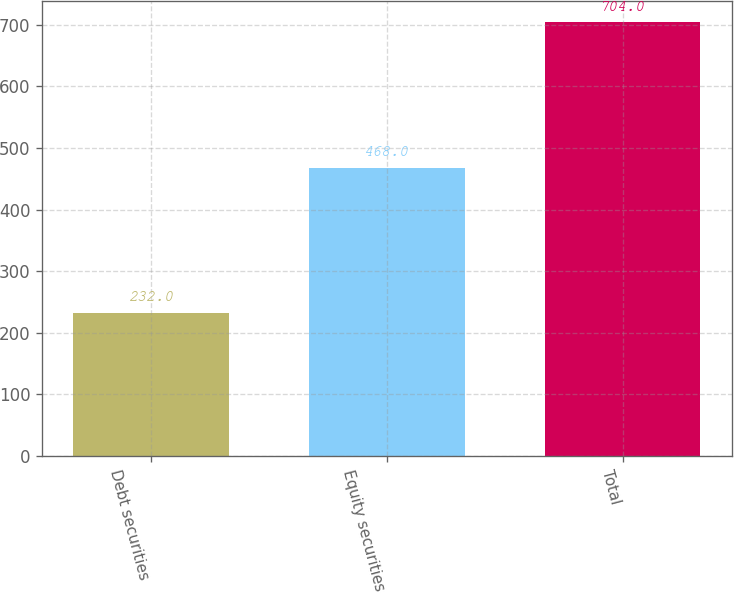Convert chart. <chart><loc_0><loc_0><loc_500><loc_500><bar_chart><fcel>Debt securities<fcel>Equity securities<fcel>Total<nl><fcel>232<fcel>468<fcel>704<nl></chart> 